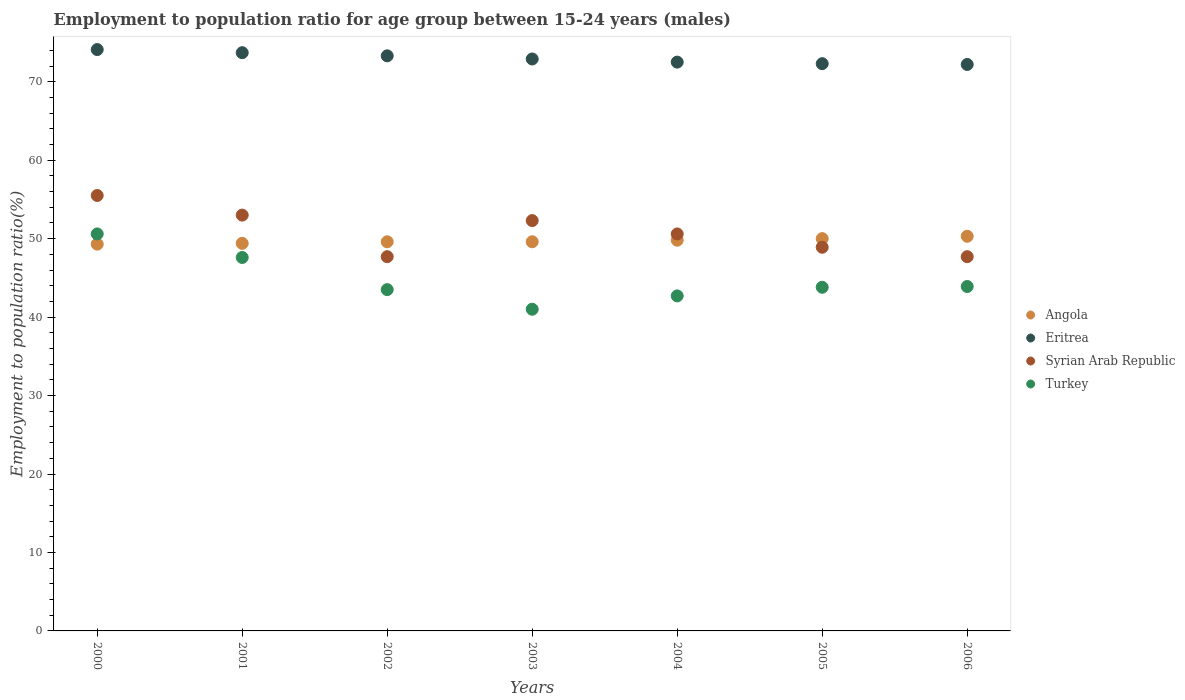How many different coloured dotlines are there?
Your answer should be compact. 4. Is the number of dotlines equal to the number of legend labels?
Offer a very short reply. Yes. What is the employment to population ratio in Eritrea in 2000?
Provide a succinct answer. 74.1. Across all years, what is the maximum employment to population ratio in Angola?
Provide a short and direct response. 50.3. Across all years, what is the minimum employment to population ratio in Eritrea?
Give a very brief answer. 72.2. In which year was the employment to population ratio in Eritrea maximum?
Provide a short and direct response. 2000. What is the total employment to population ratio in Eritrea in the graph?
Your response must be concise. 511. What is the difference between the employment to population ratio in Syrian Arab Republic in 2004 and that in 2005?
Your response must be concise. 1.7. What is the difference between the employment to population ratio in Eritrea in 2006 and the employment to population ratio in Turkey in 2003?
Offer a terse response. 31.2. What is the average employment to population ratio in Syrian Arab Republic per year?
Ensure brevity in your answer.  50.81. In the year 2000, what is the difference between the employment to population ratio in Angola and employment to population ratio in Syrian Arab Republic?
Provide a short and direct response. -6.2. In how many years, is the employment to population ratio in Angola greater than 10 %?
Your response must be concise. 7. What is the ratio of the employment to population ratio in Eritrea in 2003 to that in 2005?
Offer a very short reply. 1.01. Is the employment to population ratio in Syrian Arab Republic in 2003 less than that in 2004?
Your answer should be very brief. No. Is the difference between the employment to population ratio in Angola in 2001 and 2004 greater than the difference between the employment to population ratio in Syrian Arab Republic in 2001 and 2004?
Keep it short and to the point. No. What is the difference between the highest and the lowest employment to population ratio in Angola?
Your answer should be compact. 1. In how many years, is the employment to population ratio in Angola greater than the average employment to population ratio in Angola taken over all years?
Offer a terse response. 3. Is the sum of the employment to population ratio in Eritrea in 2005 and 2006 greater than the maximum employment to population ratio in Turkey across all years?
Your answer should be very brief. Yes. Does the employment to population ratio in Syrian Arab Republic monotonically increase over the years?
Offer a terse response. No. How many years are there in the graph?
Ensure brevity in your answer.  7. Does the graph contain any zero values?
Your answer should be compact. No. Where does the legend appear in the graph?
Offer a very short reply. Center right. How are the legend labels stacked?
Keep it short and to the point. Vertical. What is the title of the graph?
Offer a very short reply. Employment to population ratio for age group between 15-24 years (males). Does "Serbia" appear as one of the legend labels in the graph?
Ensure brevity in your answer.  No. What is the Employment to population ratio(%) of Angola in 2000?
Keep it short and to the point. 49.3. What is the Employment to population ratio(%) in Eritrea in 2000?
Give a very brief answer. 74.1. What is the Employment to population ratio(%) of Syrian Arab Republic in 2000?
Keep it short and to the point. 55.5. What is the Employment to population ratio(%) in Turkey in 2000?
Give a very brief answer. 50.6. What is the Employment to population ratio(%) of Angola in 2001?
Provide a succinct answer. 49.4. What is the Employment to population ratio(%) in Eritrea in 2001?
Offer a terse response. 73.7. What is the Employment to population ratio(%) of Turkey in 2001?
Offer a terse response. 47.6. What is the Employment to population ratio(%) of Angola in 2002?
Your answer should be very brief. 49.6. What is the Employment to population ratio(%) in Eritrea in 2002?
Provide a succinct answer. 73.3. What is the Employment to population ratio(%) of Syrian Arab Republic in 2002?
Make the answer very short. 47.7. What is the Employment to population ratio(%) in Turkey in 2002?
Offer a very short reply. 43.5. What is the Employment to population ratio(%) of Angola in 2003?
Your answer should be compact. 49.6. What is the Employment to population ratio(%) of Eritrea in 2003?
Provide a short and direct response. 72.9. What is the Employment to population ratio(%) in Syrian Arab Republic in 2003?
Give a very brief answer. 52.3. What is the Employment to population ratio(%) of Angola in 2004?
Your answer should be compact. 49.8. What is the Employment to population ratio(%) in Eritrea in 2004?
Your response must be concise. 72.5. What is the Employment to population ratio(%) of Syrian Arab Republic in 2004?
Provide a succinct answer. 50.6. What is the Employment to population ratio(%) in Turkey in 2004?
Your response must be concise. 42.7. What is the Employment to population ratio(%) of Angola in 2005?
Give a very brief answer. 50. What is the Employment to population ratio(%) in Eritrea in 2005?
Your answer should be compact. 72.3. What is the Employment to population ratio(%) of Syrian Arab Republic in 2005?
Offer a very short reply. 48.9. What is the Employment to population ratio(%) of Turkey in 2005?
Your answer should be compact. 43.8. What is the Employment to population ratio(%) in Angola in 2006?
Offer a very short reply. 50.3. What is the Employment to population ratio(%) of Eritrea in 2006?
Ensure brevity in your answer.  72.2. What is the Employment to population ratio(%) of Syrian Arab Republic in 2006?
Your answer should be very brief. 47.7. What is the Employment to population ratio(%) of Turkey in 2006?
Offer a terse response. 43.9. Across all years, what is the maximum Employment to population ratio(%) of Angola?
Provide a short and direct response. 50.3. Across all years, what is the maximum Employment to population ratio(%) in Eritrea?
Your response must be concise. 74.1. Across all years, what is the maximum Employment to population ratio(%) of Syrian Arab Republic?
Provide a succinct answer. 55.5. Across all years, what is the maximum Employment to population ratio(%) of Turkey?
Your answer should be compact. 50.6. Across all years, what is the minimum Employment to population ratio(%) of Angola?
Your answer should be compact. 49.3. Across all years, what is the minimum Employment to population ratio(%) of Eritrea?
Offer a terse response. 72.2. Across all years, what is the minimum Employment to population ratio(%) in Syrian Arab Republic?
Offer a very short reply. 47.7. What is the total Employment to population ratio(%) in Angola in the graph?
Keep it short and to the point. 348. What is the total Employment to population ratio(%) of Eritrea in the graph?
Your response must be concise. 511. What is the total Employment to population ratio(%) in Syrian Arab Republic in the graph?
Keep it short and to the point. 355.7. What is the total Employment to population ratio(%) in Turkey in the graph?
Your answer should be very brief. 313.1. What is the difference between the Employment to population ratio(%) in Angola in 2000 and that in 2001?
Make the answer very short. -0.1. What is the difference between the Employment to population ratio(%) of Syrian Arab Republic in 2000 and that in 2001?
Your response must be concise. 2.5. What is the difference between the Employment to population ratio(%) of Turkey in 2000 and that in 2001?
Ensure brevity in your answer.  3. What is the difference between the Employment to population ratio(%) in Angola in 2000 and that in 2002?
Provide a short and direct response. -0.3. What is the difference between the Employment to population ratio(%) of Syrian Arab Republic in 2000 and that in 2003?
Give a very brief answer. 3.2. What is the difference between the Employment to population ratio(%) of Turkey in 2000 and that in 2003?
Your answer should be very brief. 9.6. What is the difference between the Employment to population ratio(%) of Eritrea in 2000 and that in 2005?
Offer a very short reply. 1.8. What is the difference between the Employment to population ratio(%) in Turkey in 2000 and that in 2005?
Offer a very short reply. 6.8. What is the difference between the Employment to population ratio(%) of Angola in 2001 and that in 2002?
Provide a short and direct response. -0.2. What is the difference between the Employment to population ratio(%) of Turkey in 2001 and that in 2003?
Provide a short and direct response. 6.6. What is the difference between the Employment to population ratio(%) of Angola in 2001 and that in 2004?
Your answer should be compact. -0.4. What is the difference between the Employment to population ratio(%) of Eritrea in 2001 and that in 2004?
Your answer should be very brief. 1.2. What is the difference between the Employment to population ratio(%) of Syrian Arab Republic in 2001 and that in 2004?
Provide a succinct answer. 2.4. What is the difference between the Employment to population ratio(%) of Angola in 2001 and that in 2005?
Ensure brevity in your answer.  -0.6. What is the difference between the Employment to population ratio(%) in Eritrea in 2001 and that in 2005?
Ensure brevity in your answer.  1.4. What is the difference between the Employment to population ratio(%) of Syrian Arab Republic in 2001 and that in 2005?
Keep it short and to the point. 4.1. What is the difference between the Employment to population ratio(%) in Angola in 2001 and that in 2006?
Give a very brief answer. -0.9. What is the difference between the Employment to population ratio(%) of Eritrea in 2001 and that in 2006?
Your response must be concise. 1.5. What is the difference between the Employment to population ratio(%) in Syrian Arab Republic in 2001 and that in 2006?
Keep it short and to the point. 5.3. What is the difference between the Employment to population ratio(%) of Turkey in 2001 and that in 2006?
Provide a succinct answer. 3.7. What is the difference between the Employment to population ratio(%) in Syrian Arab Republic in 2002 and that in 2003?
Offer a very short reply. -4.6. What is the difference between the Employment to population ratio(%) of Angola in 2002 and that in 2004?
Your answer should be compact. -0.2. What is the difference between the Employment to population ratio(%) of Eritrea in 2002 and that in 2004?
Your answer should be very brief. 0.8. What is the difference between the Employment to population ratio(%) of Syrian Arab Republic in 2002 and that in 2004?
Give a very brief answer. -2.9. What is the difference between the Employment to population ratio(%) of Turkey in 2002 and that in 2004?
Your response must be concise. 0.8. What is the difference between the Employment to population ratio(%) in Eritrea in 2002 and that in 2005?
Give a very brief answer. 1. What is the difference between the Employment to population ratio(%) in Turkey in 2002 and that in 2005?
Make the answer very short. -0.3. What is the difference between the Employment to population ratio(%) of Angola in 2002 and that in 2006?
Your answer should be very brief. -0.7. What is the difference between the Employment to population ratio(%) in Syrian Arab Republic in 2002 and that in 2006?
Your response must be concise. 0. What is the difference between the Employment to population ratio(%) in Angola in 2003 and that in 2004?
Ensure brevity in your answer.  -0.2. What is the difference between the Employment to population ratio(%) in Eritrea in 2003 and that in 2004?
Ensure brevity in your answer.  0.4. What is the difference between the Employment to population ratio(%) in Turkey in 2003 and that in 2004?
Offer a very short reply. -1.7. What is the difference between the Employment to population ratio(%) in Syrian Arab Republic in 2003 and that in 2005?
Give a very brief answer. 3.4. What is the difference between the Employment to population ratio(%) of Angola in 2003 and that in 2006?
Make the answer very short. -0.7. What is the difference between the Employment to population ratio(%) of Turkey in 2003 and that in 2006?
Offer a terse response. -2.9. What is the difference between the Employment to population ratio(%) of Angola in 2004 and that in 2005?
Make the answer very short. -0.2. What is the difference between the Employment to population ratio(%) of Turkey in 2004 and that in 2005?
Ensure brevity in your answer.  -1.1. What is the difference between the Employment to population ratio(%) in Angola in 2004 and that in 2006?
Provide a short and direct response. -0.5. What is the difference between the Employment to population ratio(%) of Eritrea in 2004 and that in 2006?
Your answer should be very brief. 0.3. What is the difference between the Employment to population ratio(%) in Syrian Arab Republic in 2004 and that in 2006?
Offer a terse response. 2.9. What is the difference between the Employment to population ratio(%) in Turkey in 2004 and that in 2006?
Your answer should be very brief. -1.2. What is the difference between the Employment to population ratio(%) of Angola in 2005 and that in 2006?
Provide a short and direct response. -0.3. What is the difference between the Employment to population ratio(%) of Syrian Arab Republic in 2005 and that in 2006?
Keep it short and to the point. 1.2. What is the difference between the Employment to population ratio(%) of Angola in 2000 and the Employment to population ratio(%) of Eritrea in 2001?
Your answer should be very brief. -24.4. What is the difference between the Employment to population ratio(%) of Eritrea in 2000 and the Employment to population ratio(%) of Syrian Arab Republic in 2001?
Give a very brief answer. 21.1. What is the difference between the Employment to population ratio(%) of Eritrea in 2000 and the Employment to population ratio(%) of Turkey in 2001?
Provide a succinct answer. 26.5. What is the difference between the Employment to population ratio(%) in Syrian Arab Republic in 2000 and the Employment to population ratio(%) in Turkey in 2001?
Provide a succinct answer. 7.9. What is the difference between the Employment to population ratio(%) of Angola in 2000 and the Employment to population ratio(%) of Syrian Arab Republic in 2002?
Your answer should be compact. 1.6. What is the difference between the Employment to population ratio(%) in Eritrea in 2000 and the Employment to population ratio(%) in Syrian Arab Republic in 2002?
Keep it short and to the point. 26.4. What is the difference between the Employment to population ratio(%) in Eritrea in 2000 and the Employment to population ratio(%) in Turkey in 2002?
Provide a succinct answer. 30.6. What is the difference between the Employment to population ratio(%) in Angola in 2000 and the Employment to population ratio(%) in Eritrea in 2003?
Offer a terse response. -23.6. What is the difference between the Employment to population ratio(%) in Eritrea in 2000 and the Employment to population ratio(%) in Syrian Arab Republic in 2003?
Keep it short and to the point. 21.8. What is the difference between the Employment to population ratio(%) in Eritrea in 2000 and the Employment to population ratio(%) in Turkey in 2003?
Offer a terse response. 33.1. What is the difference between the Employment to population ratio(%) in Angola in 2000 and the Employment to population ratio(%) in Eritrea in 2004?
Give a very brief answer. -23.2. What is the difference between the Employment to population ratio(%) of Eritrea in 2000 and the Employment to population ratio(%) of Syrian Arab Republic in 2004?
Make the answer very short. 23.5. What is the difference between the Employment to population ratio(%) in Eritrea in 2000 and the Employment to population ratio(%) in Turkey in 2004?
Provide a short and direct response. 31.4. What is the difference between the Employment to population ratio(%) in Angola in 2000 and the Employment to population ratio(%) in Turkey in 2005?
Provide a succinct answer. 5.5. What is the difference between the Employment to population ratio(%) in Eritrea in 2000 and the Employment to population ratio(%) in Syrian Arab Republic in 2005?
Your response must be concise. 25.2. What is the difference between the Employment to population ratio(%) of Eritrea in 2000 and the Employment to population ratio(%) of Turkey in 2005?
Provide a succinct answer. 30.3. What is the difference between the Employment to population ratio(%) of Syrian Arab Republic in 2000 and the Employment to population ratio(%) of Turkey in 2005?
Offer a very short reply. 11.7. What is the difference between the Employment to population ratio(%) of Angola in 2000 and the Employment to population ratio(%) of Eritrea in 2006?
Keep it short and to the point. -22.9. What is the difference between the Employment to population ratio(%) in Angola in 2000 and the Employment to population ratio(%) in Syrian Arab Republic in 2006?
Give a very brief answer. 1.6. What is the difference between the Employment to population ratio(%) of Angola in 2000 and the Employment to population ratio(%) of Turkey in 2006?
Provide a succinct answer. 5.4. What is the difference between the Employment to population ratio(%) in Eritrea in 2000 and the Employment to population ratio(%) in Syrian Arab Republic in 2006?
Provide a short and direct response. 26.4. What is the difference between the Employment to population ratio(%) of Eritrea in 2000 and the Employment to population ratio(%) of Turkey in 2006?
Provide a short and direct response. 30.2. What is the difference between the Employment to population ratio(%) in Syrian Arab Republic in 2000 and the Employment to population ratio(%) in Turkey in 2006?
Your answer should be compact. 11.6. What is the difference between the Employment to population ratio(%) in Angola in 2001 and the Employment to population ratio(%) in Eritrea in 2002?
Your answer should be very brief. -23.9. What is the difference between the Employment to population ratio(%) of Angola in 2001 and the Employment to population ratio(%) of Syrian Arab Republic in 2002?
Your answer should be compact. 1.7. What is the difference between the Employment to population ratio(%) of Eritrea in 2001 and the Employment to population ratio(%) of Turkey in 2002?
Make the answer very short. 30.2. What is the difference between the Employment to population ratio(%) in Angola in 2001 and the Employment to population ratio(%) in Eritrea in 2003?
Your answer should be compact. -23.5. What is the difference between the Employment to population ratio(%) in Angola in 2001 and the Employment to population ratio(%) in Syrian Arab Republic in 2003?
Ensure brevity in your answer.  -2.9. What is the difference between the Employment to population ratio(%) in Angola in 2001 and the Employment to population ratio(%) in Turkey in 2003?
Provide a short and direct response. 8.4. What is the difference between the Employment to population ratio(%) in Eritrea in 2001 and the Employment to population ratio(%) in Syrian Arab Republic in 2003?
Offer a terse response. 21.4. What is the difference between the Employment to population ratio(%) of Eritrea in 2001 and the Employment to population ratio(%) of Turkey in 2003?
Give a very brief answer. 32.7. What is the difference between the Employment to population ratio(%) in Angola in 2001 and the Employment to population ratio(%) in Eritrea in 2004?
Give a very brief answer. -23.1. What is the difference between the Employment to population ratio(%) in Eritrea in 2001 and the Employment to population ratio(%) in Syrian Arab Republic in 2004?
Offer a terse response. 23.1. What is the difference between the Employment to population ratio(%) in Angola in 2001 and the Employment to population ratio(%) in Eritrea in 2005?
Make the answer very short. -22.9. What is the difference between the Employment to population ratio(%) of Angola in 2001 and the Employment to population ratio(%) of Syrian Arab Republic in 2005?
Provide a succinct answer. 0.5. What is the difference between the Employment to population ratio(%) of Eritrea in 2001 and the Employment to population ratio(%) of Syrian Arab Republic in 2005?
Provide a succinct answer. 24.8. What is the difference between the Employment to population ratio(%) in Eritrea in 2001 and the Employment to population ratio(%) in Turkey in 2005?
Your answer should be very brief. 29.9. What is the difference between the Employment to population ratio(%) in Syrian Arab Republic in 2001 and the Employment to population ratio(%) in Turkey in 2005?
Make the answer very short. 9.2. What is the difference between the Employment to population ratio(%) in Angola in 2001 and the Employment to population ratio(%) in Eritrea in 2006?
Your answer should be very brief. -22.8. What is the difference between the Employment to population ratio(%) of Eritrea in 2001 and the Employment to population ratio(%) of Syrian Arab Republic in 2006?
Your answer should be compact. 26. What is the difference between the Employment to population ratio(%) of Eritrea in 2001 and the Employment to population ratio(%) of Turkey in 2006?
Keep it short and to the point. 29.8. What is the difference between the Employment to population ratio(%) in Syrian Arab Republic in 2001 and the Employment to population ratio(%) in Turkey in 2006?
Offer a terse response. 9.1. What is the difference between the Employment to population ratio(%) in Angola in 2002 and the Employment to population ratio(%) in Eritrea in 2003?
Give a very brief answer. -23.3. What is the difference between the Employment to population ratio(%) of Eritrea in 2002 and the Employment to population ratio(%) of Syrian Arab Republic in 2003?
Your answer should be very brief. 21. What is the difference between the Employment to population ratio(%) of Eritrea in 2002 and the Employment to population ratio(%) of Turkey in 2003?
Provide a short and direct response. 32.3. What is the difference between the Employment to population ratio(%) of Syrian Arab Republic in 2002 and the Employment to population ratio(%) of Turkey in 2003?
Offer a very short reply. 6.7. What is the difference between the Employment to population ratio(%) in Angola in 2002 and the Employment to population ratio(%) in Eritrea in 2004?
Provide a short and direct response. -22.9. What is the difference between the Employment to population ratio(%) in Eritrea in 2002 and the Employment to population ratio(%) in Syrian Arab Republic in 2004?
Provide a succinct answer. 22.7. What is the difference between the Employment to population ratio(%) in Eritrea in 2002 and the Employment to population ratio(%) in Turkey in 2004?
Your response must be concise. 30.6. What is the difference between the Employment to population ratio(%) in Syrian Arab Republic in 2002 and the Employment to population ratio(%) in Turkey in 2004?
Give a very brief answer. 5. What is the difference between the Employment to population ratio(%) of Angola in 2002 and the Employment to population ratio(%) of Eritrea in 2005?
Provide a succinct answer. -22.7. What is the difference between the Employment to population ratio(%) of Angola in 2002 and the Employment to population ratio(%) of Turkey in 2005?
Offer a very short reply. 5.8. What is the difference between the Employment to population ratio(%) of Eritrea in 2002 and the Employment to population ratio(%) of Syrian Arab Republic in 2005?
Provide a succinct answer. 24.4. What is the difference between the Employment to population ratio(%) in Eritrea in 2002 and the Employment to population ratio(%) in Turkey in 2005?
Provide a succinct answer. 29.5. What is the difference between the Employment to population ratio(%) of Angola in 2002 and the Employment to population ratio(%) of Eritrea in 2006?
Give a very brief answer. -22.6. What is the difference between the Employment to population ratio(%) of Angola in 2002 and the Employment to population ratio(%) of Syrian Arab Republic in 2006?
Keep it short and to the point. 1.9. What is the difference between the Employment to population ratio(%) in Eritrea in 2002 and the Employment to population ratio(%) in Syrian Arab Republic in 2006?
Your response must be concise. 25.6. What is the difference between the Employment to population ratio(%) of Eritrea in 2002 and the Employment to population ratio(%) of Turkey in 2006?
Your response must be concise. 29.4. What is the difference between the Employment to population ratio(%) in Syrian Arab Republic in 2002 and the Employment to population ratio(%) in Turkey in 2006?
Ensure brevity in your answer.  3.8. What is the difference between the Employment to population ratio(%) in Angola in 2003 and the Employment to population ratio(%) in Eritrea in 2004?
Your response must be concise. -22.9. What is the difference between the Employment to population ratio(%) of Angola in 2003 and the Employment to population ratio(%) of Syrian Arab Republic in 2004?
Your answer should be very brief. -1. What is the difference between the Employment to population ratio(%) of Eritrea in 2003 and the Employment to population ratio(%) of Syrian Arab Republic in 2004?
Provide a succinct answer. 22.3. What is the difference between the Employment to population ratio(%) in Eritrea in 2003 and the Employment to population ratio(%) in Turkey in 2004?
Your answer should be very brief. 30.2. What is the difference between the Employment to population ratio(%) in Syrian Arab Republic in 2003 and the Employment to population ratio(%) in Turkey in 2004?
Offer a very short reply. 9.6. What is the difference between the Employment to population ratio(%) in Angola in 2003 and the Employment to population ratio(%) in Eritrea in 2005?
Give a very brief answer. -22.7. What is the difference between the Employment to population ratio(%) of Angola in 2003 and the Employment to population ratio(%) of Syrian Arab Republic in 2005?
Keep it short and to the point. 0.7. What is the difference between the Employment to population ratio(%) of Eritrea in 2003 and the Employment to population ratio(%) of Syrian Arab Republic in 2005?
Provide a succinct answer. 24. What is the difference between the Employment to population ratio(%) of Eritrea in 2003 and the Employment to population ratio(%) of Turkey in 2005?
Offer a very short reply. 29.1. What is the difference between the Employment to population ratio(%) in Syrian Arab Republic in 2003 and the Employment to population ratio(%) in Turkey in 2005?
Provide a succinct answer. 8.5. What is the difference between the Employment to population ratio(%) of Angola in 2003 and the Employment to population ratio(%) of Eritrea in 2006?
Make the answer very short. -22.6. What is the difference between the Employment to population ratio(%) in Angola in 2003 and the Employment to population ratio(%) in Syrian Arab Republic in 2006?
Your answer should be very brief. 1.9. What is the difference between the Employment to population ratio(%) in Eritrea in 2003 and the Employment to population ratio(%) in Syrian Arab Republic in 2006?
Ensure brevity in your answer.  25.2. What is the difference between the Employment to population ratio(%) in Syrian Arab Republic in 2003 and the Employment to population ratio(%) in Turkey in 2006?
Your answer should be compact. 8.4. What is the difference between the Employment to population ratio(%) of Angola in 2004 and the Employment to population ratio(%) of Eritrea in 2005?
Offer a very short reply. -22.5. What is the difference between the Employment to population ratio(%) in Eritrea in 2004 and the Employment to population ratio(%) in Syrian Arab Republic in 2005?
Your answer should be very brief. 23.6. What is the difference between the Employment to population ratio(%) in Eritrea in 2004 and the Employment to population ratio(%) in Turkey in 2005?
Give a very brief answer. 28.7. What is the difference between the Employment to population ratio(%) of Angola in 2004 and the Employment to population ratio(%) of Eritrea in 2006?
Ensure brevity in your answer.  -22.4. What is the difference between the Employment to population ratio(%) of Eritrea in 2004 and the Employment to population ratio(%) of Syrian Arab Republic in 2006?
Your answer should be compact. 24.8. What is the difference between the Employment to population ratio(%) in Eritrea in 2004 and the Employment to population ratio(%) in Turkey in 2006?
Give a very brief answer. 28.6. What is the difference between the Employment to population ratio(%) in Syrian Arab Republic in 2004 and the Employment to population ratio(%) in Turkey in 2006?
Give a very brief answer. 6.7. What is the difference between the Employment to population ratio(%) of Angola in 2005 and the Employment to population ratio(%) of Eritrea in 2006?
Provide a succinct answer. -22.2. What is the difference between the Employment to population ratio(%) of Angola in 2005 and the Employment to population ratio(%) of Syrian Arab Republic in 2006?
Give a very brief answer. 2.3. What is the difference between the Employment to population ratio(%) in Eritrea in 2005 and the Employment to population ratio(%) in Syrian Arab Republic in 2006?
Ensure brevity in your answer.  24.6. What is the difference between the Employment to population ratio(%) of Eritrea in 2005 and the Employment to population ratio(%) of Turkey in 2006?
Your answer should be compact. 28.4. What is the difference between the Employment to population ratio(%) of Syrian Arab Republic in 2005 and the Employment to population ratio(%) of Turkey in 2006?
Give a very brief answer. 5. What is the average Employment to population ratio(%) in Angola per year?
Provide a succinct answer. 49.71. What is the average Employment to population ratio(%) of Syrian Arab Republic per year?
Offer a very short reply. 50.81. What is the average Employment to population ratio(%) in Turkey per year?
Your answer should be compact. 44.73. In the year 2000, what is the difference between the Employment to population ratio(%) of Angola and Employment to population ratio(%) of Eritrea?
Make the answer very short. -24.8. In the year 2000, what is the difference between the Employment to population ratio(%) in Angola and Employment to population ratio(%) in Syrian Arab Republic?
Give a very brief answer. -6.2. In the year 2000, what is the difference between the Employment to population ratio(%) of Eritrea and Employment to population ratio(%) of Turkey?
Keep it short and to the point. 23.5. In the year 2000, what is the difference between the Employment to population ratio(%) in Syrian Arab Republic and Employment to population ratio(%) in Turkey?
Your answer should be compact. 4.9. In the year 2001, what is the difference between the Employment to population ratio(%) in Angola and Employment to population ratio(%) in Eritrea?
Your response must be concise. -24.3. In the year 2001, what is the difference between the Employment to population ratio(%) in Eritrea and Employment to population ratio(%) in Syrian Arab Republic?
Provide a succinct answer. 20.7. In the year 2001, what is the difference between the Employment to population ratio(%) of Eritrea and Employment to population ratio(%) of Turkey?
Give a very brief answer. 26.1. In the year 2002, what is the difference between the Employment to population ratio(%) of Angola and Employment to population ratio(%) of Eritrea?
Give a very brief answer. -23.7. In the year 2002, what is the difference between the Employment to population ratio(%) in Eritrea and Employment to population ratio(%) in Syrian Arab Republic?
Offer a terse response. 25.6. In the year 2002, what is the difference between the Employment to population ratio(%) of Eritrea and Employment to population ratio(%) of Turkey?
Your response must be concise. 29.8. In the year 2002, what is the difference between the Employment to population ratio(%) in Syrian Arab Republic and Employment to population ratio(%) in Turkey?
Give a very brief answer. 4.2. In the year 2003, what is the difference between the Employment to population ratio(%) of Angola and Employment to population ratio(%) of Eritrea?
Your answer should be compact. -23.3. In the year 2003, what is the difference between the Employment to population ratio(%) in Angola and Employment to population ratio(%) in Turkey?
Make the answer very short. 8.6. In the year 2003, what is the difference between the Employment to population ratio(%) of Eritrea and Employment to population ratio(%) of Syrian Arab Republic?
Ensure brevity in your answer.  20.6. In the year 2003, what is the difference between the Employment to population ratio(%) in Eritrea and Employment to population ratio(%) in Turkey?
Offer a terse response. 31.9. In the year 2004, what is the difference between the Employment to population ratio(%) of Angola and Employment to population ratio(%) of Eritrea?
Provide a succinct answer. -22.7. In the year 2004, what is the difference between the Employment to population ratio(%) of Eritrea and Employment to population ratio(%) of Syrian Arab Republic?
Ensure brevity in your answer.  21.9. In the year 2004, what is the difference between the Employment to population ratio(%) of Eritrea and Employment to population ratio(%) of Turkey?
Offer a terse response. 29.8. In the year 2004, what is the difference between the Employment to population ratio(%) of Syrian Arab Republic and Employment to population ratio(%) of Turkey?
Offer a very short reply. 7.9. In the year 2005, what is the difference between the Employment to population ratio(%) of Angola and Employment to population ratio(%) of Eritrea?
Keep it short and to the point. -22.3. In the year 2005, what is the difference between the Employment to population ratio(%) in Angola and Employment to population ratio(%) in Syrian Arab Republic?
Provide a short and direct response. 1.1. In the year 2005, what is the difference between the Employment to population ratio(%) of Eritrea and Employment to population ratio(%) of Syrian Arab Republic?
Your response must be concise. 23.4. In the year 2005, what is the difference between the Employment to population ratio(%) in Syrian Arab Republic and Employment to population ratio(%) in Turkey?
Your answer should be very brief. 5.1. In the year 2006, what is the difference between the Employment to population ratio(%) of Angola and Employment to population ratio(%) of Eritrea?
Your answer should be very brief. -21.9. In the year 2006, what is the difference between the Employment to population ratio(%) in Angola and Employment to population ratio(%) in Syrian Arab Republic?
Offer a very short reply. 2.6. In the year 2006, what is the difference between the Employment to population ratio(%) in Angola and Employment to population ratio(%) in Turkey?
Provide a succinct answer. 6.4. In the year 2006, what is the difference between the Employment to population ratio(%) of Eritrea and Employment to population ratio(%) of Syrian Arab Republic?
Ensure brevity in your answer.  24.5. In the year 2006, what is the difference between the Employment to population ratio(%) in Eritrea and Employment to population ratio(%) in Turkey?
Your answer should be compact. 28.3. What is the ratio of the Employment to population ratio(%) in Eritrea in 2000 to that in 2001?
Provide a short and direct response. 1.01. What is the ratio of the Employment to population ratio(%) of Syrian Arab Republic in 2000 to that in 2001?
Offer a very short reply. 1.05. What is the ratio of the Employment to population ratio(%) in Turkey in 2000 to that in 2001?
Offer a terse response. 1.06. What is the ratio of the Employment to population ratio(%) of Angola in 2000 to that in 2002?
Your response must be concise. 0.99. What is the ratio of the Employment to population ratio(%) in Eritrea in 2000 to that in 2002?
Ensure brevity in your answer.  1.01. What is the ratio of the Employment to population ratio(%) of Syrian Arab Republic in 2000 to that in 2002?
Ensure brevity in your answer.  1.16. What is the ratio of the Employment to population ratio(%) in Turkey in 2000 to that in 2002?
Your answer should be compact. 1.16. What is the ratio of the Employment to population ratio(%) of Angola in 2000 to that in 2003?
Provide a succinct answer. 0.99. What is the ratio of the Employment to population ratio(%) of Eritrea in 2000 to that in 2003?
Your answer should be compact. 1.02. What is the ratio of the Employment to population ratio(%) in Syrian Arab Republic in 2000 to that in 2003?
Offer a very short reply. 1.06. What is the ratio of the Employment to population ratio(%) of Turkey in 2000 to that in 2003?
Make the answer very short. 1.23. What is the ratio of the Employment to population ratio(%) of Angola in 2000 to that in 2004?
Make the answer very short. 0.99. What is the ratio of the Employment to population ratio(%) in Eritrea in 2000 to that in 2004?
Provide a short and direct response. 1.02. What is the ratio of the Employment to population ratio(%) in Syrian Arab Republic in 2000 to that in 2004?
Your answer should be compact. 1.1. What is the ratio of the Employment to population ratio(%) in Turkey in 2000 to that in 2004?
Your response must be concise. 1.19. What is the ratio of the Employment to population ratio(%) in Eritrea in 2000 to that in 2005?
Ensure brevity in your answer.  1.02. What is the ratio of the Employment to population ratio(%) of Syrian Arab Republic in 2000 to that in 2005?
Offer a terse response. 1.14. What is the ratio of the Employment to population ratio(%) of Turkey in 2000 to that in 2005?
Offer a terse response. 1.16. What is the ratio of the Employment to population ratio(%) of Angola in 2000 to that in 2006?
Make the answer very short. 0.98. What is the ratio of the Employment to population ratio(%) in Eritrea in 2000 to that in 2006?
Provide a succinct answer. 1.03. What is the ratio of the Employment to population ratio(%) in Syrian Arab Republic in 2000 to that in 2006?
Make the answer very short. 1.16. What is the ratio of the Employment to population ratio(%) of Turkey in 2000 to that in 2006?
Your response must be concise. 1.15. What is the ratio of the Employment to population ratio(%) in Angola in 2001 to that in 2002?
Offer a terse response. 1. What is the ratio of the Employment to population ratio(%) of Eritrea in 2001 to that in 2002?
Provide a short and direct response. 1.01. What is the ratio of the Employment to population ratio(%) in Syrian Arab Republic in 2001 to that in 2002?
Offer a very short reply. 1.11. What is the ratio of the Employment to population ratio(%) in Turkey in 2001 to that in 2002?
Provide a short and direct response. 1.09. What is the ratio of the Employment to population ratio(%) in Angola in 2001 to that in 2003?
Your answer should be very brief. 1. What is the ratio of the Employment to population ratio(%) of Syrian Arab Republic in 2001 to that in 2003?
Your response must be concise. 1.01. What is the ratio of the Employment to population ratio(%) in Turkey in 2001 to that in 2003?
Provide a succinct answer. 1.16. What is the ratio of the Employment to population ratio(%) of Angola in 2001 to that in 2004?
Make the answer very short. 0.99. What is the ratio of the Employment to population ratio(%) in Eritrea in 2001 to that in 2004?
Offer a terse response. 1.02. What is the ratio of the Employment to population ratio(%) of Syrian Arab Republic in 2001 to that in 2004?
Offer a very short reply. 1.05. What is the ratio of the Employment to population ratio(%) of Turkey in 2001 to that in 2004?
Offer a very short reply. 1.11. What is the ratio of the Employment to population ratio(%) in Angola in 2001 to that in 2005?
Make the answer very short. 0.99. What is the ratio of the Employment to population ratio(%) in Eritrea in 2001 to that in 2005?
Your answer should be very brief. 1.02. What is the ratio of the Employment to population ratio(%) in Syrian Arab Republic in 2001 to that in 2005?
Your answer should be very brief. 1.08. What is the ratio of the Employment to population ratio(%) in Turkey in 2001 to that in 2005?
Your response must be concise. 1.09. What is the ratio of the Employment to population ratio(%) in Angola in 2001 to that in 2006?
Your answer should be very brief. 0.98. What is the ratio of the Employment to population ratio(%) of Eritrea in 2001 to that in 2006?
Provide a short and direct response. 1.02. What is the ratio of the Employment to population ratio(%) of Syrian Arab Republic in 2001 to that in 2006?
Offer a terse response. 1.11. What is the ratio of the Employment to population ratio(%) in Turkey in 2001 to that in 2006?
Provide a short and direct response. 1.08. What is the ratio of the Employment to population ratio(%) of Syrian Arab Republic in 2002 to that in 2003?
Make the answer very short. 0.91. What is the ratio of the Employment to population ratio(%) of Turkey in 2002 to that in 2003?
Provide a succinct answer. 1.06. What is the ratio of the Employment to population ratio(%) in Syrian Arab Republic in 2002 to that in 2004?
Offer a terse response. 0.94. What is the ratio of the Employment to population ratio(%) of Turkey in 2002 to that in 2004?
Offer a terse response. 1.02. What is the ratio of the Employment to population ratio(%) of Eritrea in 2002 to that in 2005?
Provide a succinct answer. 1.01. What is the ratio of the Employment to population ratio(%) of Syrian Arab Republic in 2002 to that in 2005?
Offer a terse response. 0.98. What is the ratio of the Employment to population ratio(%) of Turkey in 2002 to that in 2005?
Keep it short and to the point. 0.99. What is the ratio of the Employment to population ratio(%) in Angola in 2002 to that in 2006?
Your answer should be very brief. 0.99. What is the ratio of the Employment to population ratio(%) in Eritrea in 2002 to that in 2006?
Offer a very short reply. 1.02. What is the ratio of the Employment to population ratio(%) of Turkey in 2002 to that in 2006?
Provide a short and direct response. 0.99. What is the ratio of the Employment to population ratio(%) in Angola in 2003 to that in 2004?
Offer a terse response. 1. What is the ratio of the Employment to population ratio(%) in Eritrea in 2003 to that in 2004?
Provide a short and direct response. 1.01. What is the ratio of the Employment to population ratio(%) in Syrian Arab Republic in 2003 to that in 2004?
Your response must be concise. 1.03. What is the ratio of the Employment to population ratio(%) in Turkey in 2003 to that in 2004?
Give a very brief answer. 0.96. What is the ratio of the Employment to population ratio(%) of Angola in 2003 to that in 2005?
Offer a very short reply. 0.99. What is the ratio of the Employment to population ratio(%) in Eritrea in 2003 to that in 2005?
Your response must be concise. 1.01. What is the ratio of the Employment to population ratio(%) of Syrian Arab Republic in 2003 to that in 2005?
Your answer should be very brief. 1.07. What is the ratio of the Employment to population ratio(%) in Turkey in 2003 to that in 2005?
Offer a very short reply. 0.94. What is the ratio of the Employment to population ratio(%) of Angola in 2003 to that in 2006?
Keep it short and to the point. 0.99. What is the ratio of the Employment to population ratio(%) of Eritrea in 2003 to that in 2006?
Offer a very short reply. 1.01. What is the ratio of the Employment to population ratio(%) of Syrian Arab Republic in 2003 to that in 2006?
Provide a short and direct response. 1.1. What is the ratio of the Employment to population ratio(%) of Turkey in 2003 to that in 2006?
Offer a very short reply. 0.93. What is the ratio of the Employment to population ratio(%) in Angola in 2004 to that in 2005?
Keep it short and to the point. 1. What is the ratio of the Employment to population ratio(%) of Eritrea in 2004 to that in 2005?
Your answer should be compact. 1. What is the ratio of the Employment to population ratio(%) in Syrian Arab Republic in 2004 to that in 2005?
Provide a succinct answer. 1.03. What is the ratio of the Employment to population ratio(%) of Turkey in 2004 to that in 2005?
Give a very brief answer. 0.97. What is the ratio of the Employment to population ratio(%) of Angola in 2004 to that in 2006?
Your answer should be very brief. 0.99. What is the ratio of the Employment to population ratio(%) of Syrian Arab Republic in 2004 to that in 2006?
Ensure brevity in your answer.  1.06. What is the ratio of the Employment to population ratio(%) in Turkey in 2004 to that in 2006?
Provide a succinct answer. 0.97. What is the ratio of the Employment to population ratio(%) of Syrian Arab Republic in 2005 to that in 2006?
Offer a terse response. 1.03. What is the ratio of the Employment to population ratio(%) in Turkey in 2005 to that in 2006?
Provide a short and direct response. 1. What is the difference between the highest and the second highest Employment to population ratio(%) of Angola?
Offer a terse response. 0.3. What is the difference between the highest and the second highest Employment to population ratio(%) in Eritrea?
Your answer should be very brief. 0.4. What is the difference between the highest and the lowest Employment to population ratio(%) in Angola?
Your answer should be very brief. 1. What is the difference between the highest and the lowest Employment to population ratio(%) of Eritrea?
Offer a very short reply. 1.9. What is the difference between the highest and the lowest Employment to population ratio(%) in Turkey?
Ensure brevity in your answer.  9.6. 